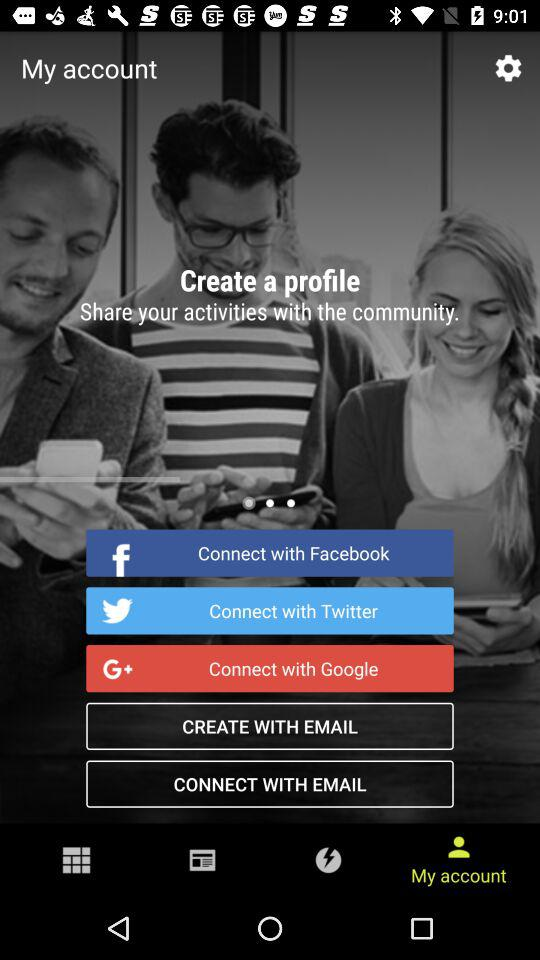How many articles are there in "Android"? There are 1,802 articles in "Android". 